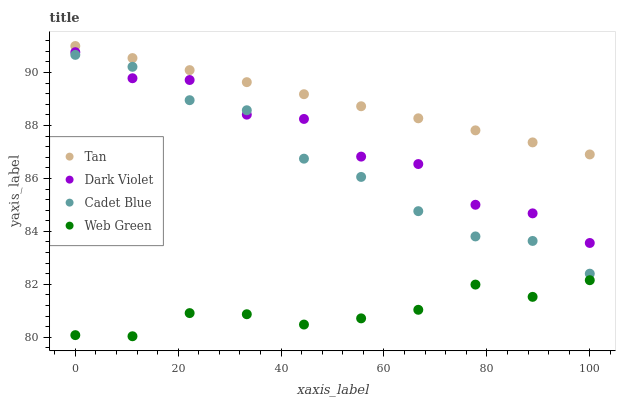Does Web Green have the minimum area under the curve?
Answer yes or no. Yes. Does Tan have the maximum area under the curve?
Answer yes or no. Yes. Does Cadet Blue have the minimum area under the curve?
Answer yes or no. No. Does Cadet Blue have the maximum area under the curve?
Answer yes or no. No. Is Tan the smoothest?
Answer yes or no. Yes. Is Dark Violet the roughest?
Answer yes or no. Yes. Is Cadet Blue the smoothest?
Answer yes or no. No. Is Cadet Blue the roughest?
Answer yes or no. No. Does Web Green have the lowest value?
Answer yes or no. Yes. Does Cadet Blue have the lowest value?
Answer yes or no. No. Does Tan have the highest value?
Answer yes or no. Yes. Does Cadet Blue have the highest value?
Answer yes or no. No. Is Dark Violet less than Tan?
Answer yes or no. Yes. Is Tan greater than Web Green?
Answer yes or no. Yes. Does Cadet Blue intersect Dark Violet?
Answer yes or no. Yes. Is Cadet Blue less than Dark Violet?
Answer yes or no. No. Is Cadet Blue greater than Dark Violet?
Answer yes or no. No. Does Dark Violet intersect Tan?
Answer yes or no. No. 